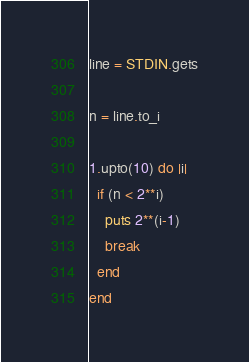Convert code to text. <code><loc_0><loc_0><loc_500><loc_500><_Ruby_>line = STDIN.gets

n = line.to_i

1.upto(10) do |i|
  if (n < 2**i)
    puts 2**(i-1)
    break
  end
end</code> 